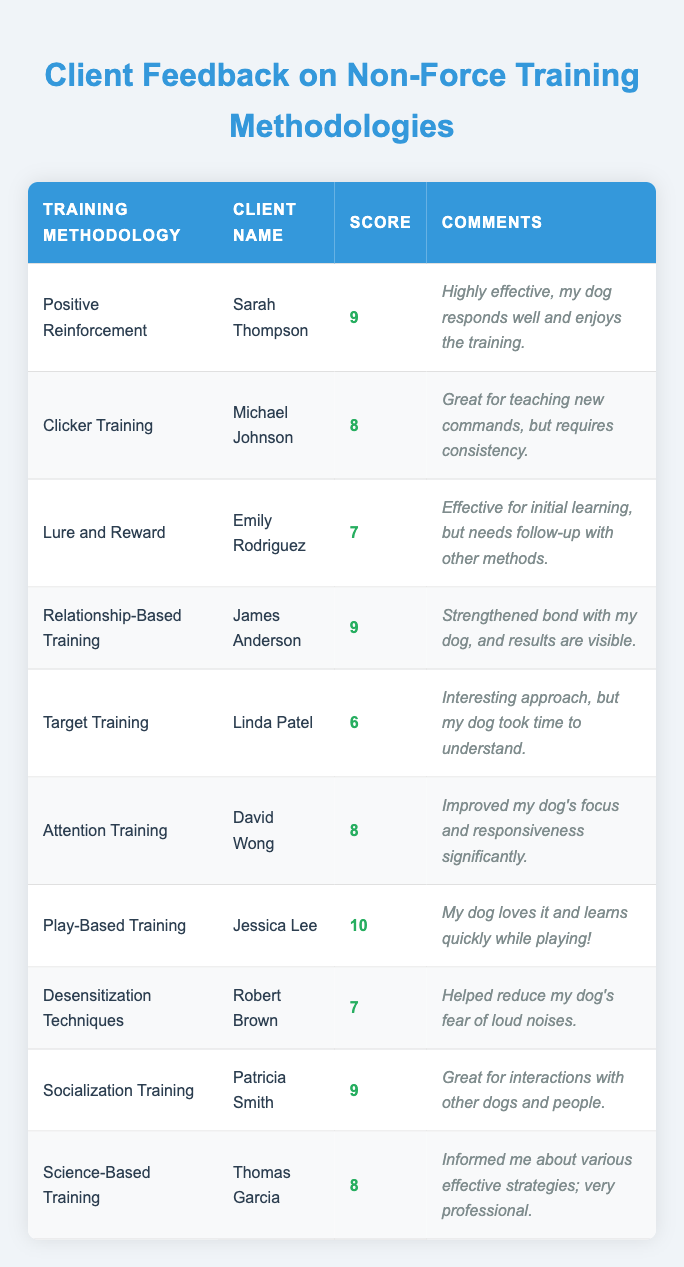What is the highest score given to a training methodology? Looking at the scores provided in the table, the highest score is 10, which was given for Play-Based Training by Jessica Lee.
Answer: 10 Which client gave a score of 6, and for which training methodology? The client who scored 6 is Linda Patel, and the training methodology is Target Training.
Answer: Linda Patel, Target Training What is the average score of all training methodologies listed? To calculate the average, sum all scores: (9 + 8 + 7 + 9 + 6 + 8 + 10 + 7 + 9 + 8) = 81. There are 10 methodologies, so divide 81 by 10 to get an average of 8.1.
Answer: 8.1 Did any clients give a score of 7 for their training methodology? Yes, two clients gave a score of 7: Emily Rodriguez for Lure and Reward, and Robert Brown for Desensitization Techniques.
Answer: Yes Which training methodology received the most positive feedback? Play-Based Training received the highest score of 10, indicating it had the most positive feedback among all the methodologies listed in the table.
Answer: Play-Based Training What was the score given to Attention Training, and what was the client's comment about it? Attention Training received a score of 8, and the client's comment was that it "Improved my dog's focus and responsiveness significantly."
Answer: 8, Improved focus and responsiveness How many clients provided feedback scores of 9 or higher? There are four clients who provided scores of 9 or higher: Sarah Thompson, James Anderson, Patricia Smith, and Jessica Lee.
Answer: 4 Was Lure and Reward considered as effective as Play-Based Training according to the scores? No, Lure and Reward was scored 7, while Play-Based Training received a score of 10, showing that Play-Based Training was considered more effective.
Answer: No Which training methodology had the least score and what feedback did the corresponding client provide? Target Training had the least score of 6, and Linda Patel mentioned it was "Interesting approach, but my dog took time to understand."
Answer: Target Training, Interesting approach 